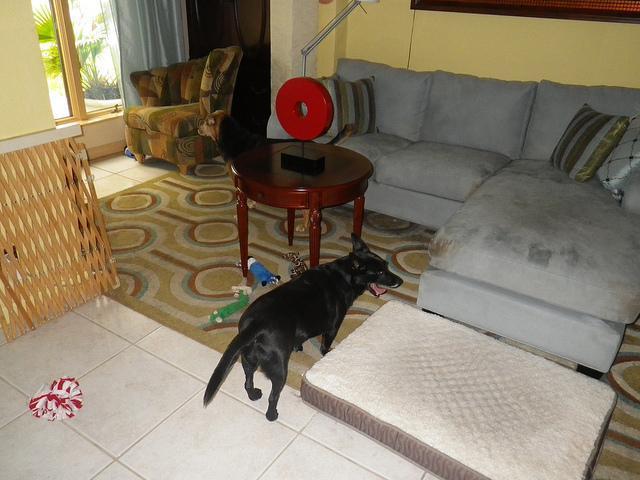How many couches are there?
Give a very brief answer. 2. How many people are wearing red shirts?
Give a very brief answer. 0. 